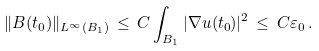Convert formula to latex. <formula><loc_0><loc_0><loc_500><loc_500>\| B ( t _ { 0 } ) \| _ { L ^ { \infty } ( B _ { 1 } ) } \, \leq \, C \int _ { B _ { 1 } } | \nabla u ( t _ { 0 } ) | ^ { 2 } \, \leq \, C \varepsilon _ { 0 } \, .</formula> 